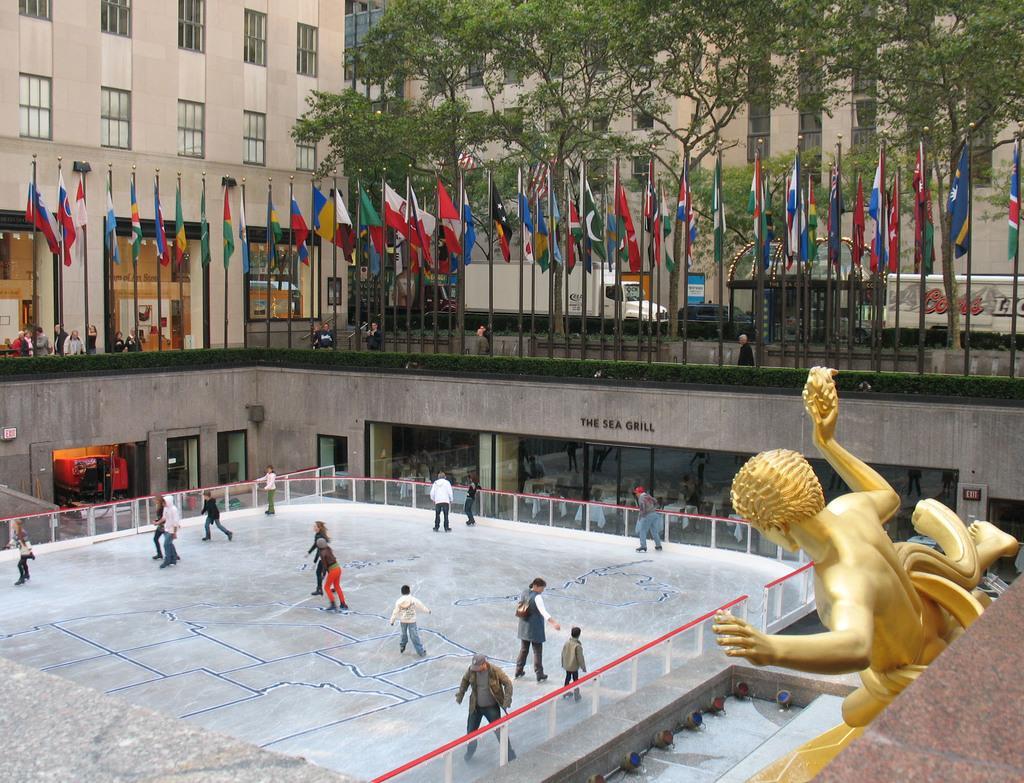Describe this image in one or two sentences. In this image I can see some people. On the right side, I can see a statue. At the top I can see the flags, trees. I can also see the vehicles and the buildings. 